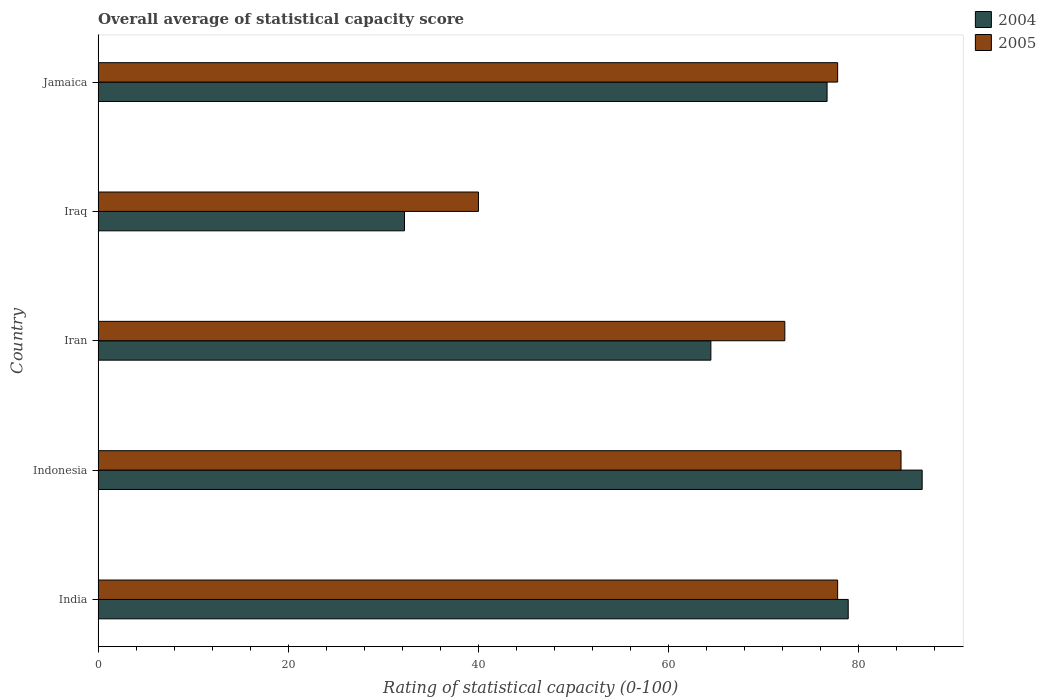How many groups of bars are there?
Give a very brief answer. 5. Are the number of bars per tick equal to the number of legend labels?
Provide a succinct answer. Yes. Are the number of bars on each tick of the Y-axis equal?
Provide a short and direct response. Yes. How many bars are there on the 2nd tick from the top?
Offer a terse response. 2. How many bars are there on the 5th tick from the bottom?
Your answer should be very brief. 2. What is the label of the 4th group of bars from the top?
Provide a succinct answer. Indonesia. In how many cases, is the number of bars for a given country not equal to the number of legend labels?
Offer a very short reply. 0. What is the rating of statistical capacity in 2004 in Iran?
Your answer should be very brief. 64.44. Across all countries, what is the maximum rating of statistical capacity in 2005?
Keep it short and to the point. 84.44. Across all countries, what is the minimum rating of statistical capacity in 2004?
Offer a terse response. 32.22. In which country was the rating of statistical capacity in 2004 maximum?
Provide a succinct answer. Indonesia. In which country was the rating of statistical capacity in 2005 minimum?
Make the answer very short. Iraq. What is the total rating of statistical capacity in 2004 in the graph?
Provide a succinct answer. 338.89. What is the difference between the rating of statistical capacity in 2004 in India and that in Indonesia?
Offer a very short reply. -7.78. What is the difference between the rating of statistical capacity in 2004 in Iran and the rating of statistical capacity in 2005 in Jamaica?
Offer a very short reply. -13.33. What is the average rating of statistical capacity in 2004 per country?
Ensure brevity in your answer.  67.78. What is the difference between the rating of statistical capacity in 2005 and rating of statistical capacity in 2004 in Indonesia?
Provide a succinct answer. -2.22. In how many countries, is the rating of statistical capacity in 2005 greater than 20 ?
Your answer should be very brief. 5. What is the ratio of the rating of statistical capacity in 2004 in Indonesia to that in Jamaica?
Offer a terse response. 1.13. What is the difference between the highest and the second highest rating of statistical capacity in 2004?
Provide a short and direct response. 7.78. What is the difference between the highest and the lowest rating of statistical capacity in 2005?
Make the answer very short. 44.44. In how many countries, is the rating of statistical capacity in 2005 greater than the average rating of statistical capacity in 2005 taken over all countries?
Your answer should be compact. 4. What does the 1st bar from the bottom in India represents?
Give a very brief answer. 2004. How many bars are there?
Your answer should be very brief. 10. What is the difference between two consecutive major ticks on the X-axis?
Give a very brief answer. 20. Are the values on the major ticks of X-axis written in scientific E-notation?
Keep it short and to the point. No. Where does the legend appear in the graph?
Offer a terse response. Top right. How are the legend labels stacked?
Make the answer very short. Vertical. What is the title of the graph?
Your answer should be very brief. Overall average of statistical capacity score. What is the label or title of the X-axis?
Provide a succinct answer. Rating of statistical capacity (0-100). What is the Rating of statistical capacity (0-100) of 2004 in India?
Offer a very short reply. 78.89. What is the Rating of statistical capacity (0-100) in 2005 in India?
Make the answer very short. 77.78. What is the Rating of statistical capacity (0-100) in 2004 in Indonesia?
Your answer should be very brief. 86.67. What is the Rating of statistical capacity (0-100) of 2005 in Indonesia?
Ensure brevity in your answer.  84.44. What is the Rating of statistical capacity (0-100) in 2004 in Iran?
Provide a short and direct response. 64.44. What is the Rating of statistical capacity (0-100) in 2005 in Iran?
Your answer should be compact. 72.22. What is the Rating of statistical capacity (0-100) of 2004 in Iraq?
Ensure brevity in your answer.  32.22. What is the Rating of statistical capacity (0-100) of 2004 in Jamaica?
Your answer should be very brief. 76.67. What is the Rating of statistical capacity (0-100) of 2005 in Jamaica?
Keep it short and to the point. 77.78. Across all countries, what is the maximum Rating of statistical capacity (0-100) in 2004?
Your answer should be very brief. 86.67. Across all countries, what is the maximum Rating of statistical capacity (0-100) in 2005?
Make the answer very short. 84.44. Across all countries, what is the minimum Rating of statistical capacity (0-100) in 2004?
Offer a terse response. 32.22. What is the total Rating of statistical capacity (0-100) of 2004 in the graph?
Your answer should be very brief. 338.89. What is the total Rating of statistical capacity (0-100) of 2005 in the graph?
Offer a terse response. 352.22. What is the difference between the Rating of statistical capacity (0-100) in 2004 in India and that in Indonesia?
Ensure brevity in your answer.  -7.78. What is the difference between the Rating of statistical capacity (0-100) in 2005 in India and that in Indonesia?
Make the answer very short. -6.67. What is the difference between the Rating of statistical capacity (0-100) in 2004 in India and that in Iran?
Provide a short and direct response. 14.44. What is the difference between the Rating of statistical capacity (0-100) of 2005 in India and that in Iran?
Provide a succinct answer. 5.56. What is the difference between the Rating of statistical capacity (0-100) in 2004 in India and that in Iraq?
Keep it short and to the point. 46.67. What is the difference between the Rating of statistical capacity (0-100) of 2005 in India and that in Iraq?
Your answer should be very brief. 37.78. What is the difference between the Rating of statistical capacity (0-100) in 2004 in India and that in Jamaica?
Provide a short and direct response. 2.22. What is the difference between the Rating of statistical capacity (0-100) of 2005 in India and that in Jamaica?
Provide a short and direct response. 0. What is the difference between the Rating of statistical capacity (0-100) in 2004 in Indonesia and that in Iran?
Ensure brevity in your answer.  22.22. What is the difference between the Rating of statistical capacity (0-100) in 2005 in Indonesia and that in Iran?
Your answer should be very brief. 12.22. What is the difference between the Rating of statistical capacity (0-100) of 2004 in Indonesia and that in Iraq?
Your answer should be compact. 54.44. What is the difference between the Rating of statistical capacity (0-100) in 2005 in Indonesia and that in Iraq?
Your response must be concise. 44.44. What is the difference between the Rating of statistical capacity (0-100) of 2004 in Indonesia and that in Jamaica?
Make the answer very short. 10. What is the difference between the Rating of statistical capacity (0-100) in 2004 in Iran and that in Iraq?
Offer a very short reply. 32.22. What is the difference between the Rating of statistical capacity (0-100) in 2005 in Iran and that in Iraq?
Ensure brevity in your answer.  32.22. What is the difference between the Rating of statistical capacity (0-100) of 2004 in Iran and that in Jamaica?
Give a very brief answer. -12.22. What is the difference between the Rating of statistical capacity (0-100) in 2005 in Iran and that in Jamaica?
Your response must be concise. -5.56. What is the difference between the Rating of statistical capacity (0-100) in 2004 in Iraq and that in Jamaica?
Make the answer very short. -44.44. What is the difference between the Rating of statistical capacity (0-100) of 2005 in Iraq and that in Jamaica?
Your response must be concise. -37.78. What is the difference between the Rating of statistical capacity (0-100) of 2004 in India and the Rating of statistical capacity (0-100) of 2005 in Indonesia?
Keep it short and to the point. -5.56. What is the difference between the Rating of statistical capacity (0-100) of 2004 in India and the Rating of statistical capacity (0-100) of 2005 in Iran?
Provide a succinct answer. 6.67. What is the difference between the Rating of statistical capacity (0-100) of 2004 in India and the Rating of statistical capacity (0-100) of 2005 in Iraq?
Your answer should be very brief. 38.89. What is the difference between the Rating of statistical capacity (0-100) in 2004 in India and the Rating of statistical capacity (0-100) in 2005 in Jamaica?
Provide a succinct answer. 1.11. What is the difference between the Rating of statistical capacity (0-100) in 2004 in Indonesia and the Rating of statistical capacity (0-100) in 2005 in Iran?
Provide a short and direct response. 14.44. What is the difference between the Rating of statistical capacity (0-100) of 2004 in Indonesia and the Rating of statistical capacity (0-100) of 2005 in Iraq?
Make the answer very short. 46.67. What is the difference between the Rating of statistical capacity (0-100) in 2004 in Indonesia and the Rating of statistical capacity (0-100) in 2005 in Jamaica?
Give a very brief answer. 8.89. What is the difference between the Rating of statistical capacity (0-100) in 2004 in Iran and the Rating of statistical capacity (0-100) in 2005 in Iraq?
Give a very brief answer. 24.44. What is the difference between the Rating of statistical capacity (0-100) of 2004 in Iran and the Rating of statistical capacity (0-100) of 2005 in Jamaica?
Keep it short and to the point. -13.33. What is the difference between the Rating of statistical capacity (0-100) in 2004 in Iraq and the Rating of statistical capacity (0-100) in 2005 in Jamaica?
Keep it short and to the point. -45.56. What is the average Rating of statistical capacity (0-100) in 2004 per country?
Keep it short and to the point. 67.78. What is the average Rating of statistical capacity (0-100) in 2005 per country?
Offer a terse response. 70.44. What is the difference between the Rating of statistical capacity (0-100) in 2004 and Rating of statistical capacity (0-100) in 2005 in Indonesia?
Your answer should be very brief. 2.22. What is the difference between the Rating of statistical capacity (0-100) in 2004 and Rating of statistical capacity (0-100) in 2005 in Iran?
Ensure brevity in your answer.  -7.78. What is the difference between the Rating of statistical capacity (0-100) in 2004 and Rating of statistical capacity (0-100) in 2005 in Iraq?
Offer a very short reply. -7.78. What is the difference between the Rating of statistical capacity (0-100) of 2004 and Rating of statistical capacity (0-100) of 2005 in Jamaica?
Make the answer very short. -1.11. What is the ratio of the Rating of statistical capacity (0-100) of 2004 in India to that in Indonesia?
Keep it short and to the point. 0.91. What is the ratio of the Rating of statistical capacity (0-100) in 2005 in India to that in Indonesia?
Make the answer very short. 0.92. What is the ratio of the Rating of statistical capacity (0-100) of 2004 in India to that in Iran?
Provide a short and direct response. 1.22. What is the ratio of the Rating of statistical capacity (0-100) in 2005 in India to that in Iran?
Keep it short and to the point. 1.08. What is the ratio of the Rating of statistical capacity (0-100) of 2004 in India to that in Iraq?
Your answer should be very brief. 2.45. What is the ratio of the Rating of statistical capacity (0-100) in 2005 in India to that in Iraq?
Ensure brevity in your answer.  1.94. What is the ratio of the Rating of statistical capacity (0-100) of 2004 in Indonesia to that in Iran?
Keep it short and to the point. 1.34. What is the ratio of the Rating of statistical capacity (0-100) of 2005 in Indonesia to that in Iran?
Keep it short and to the point. 1.17. What is the ratio of the Rating of statistical capacity (0-100) of 2004 in Indonesia to that in Iraq?
Provide a succinct answer. 2.69. What is the ratio of the Rating of statistical capacity (0-100) of 2005 in Indonesia to that in Iraq?
Your response must be concise. 2.11. What is the ratio of the Rating of statistical capacity (0-100) in 2004 in Indonesia to that in Jamaica?
Give a very brief answer. 1.13. What is the ratio of the Rating of statistical capacity (0-100) in 2005 in Indonesia to that in Jamaica?
Make the answer very short. 1.09. What is the ratio of the Rating of statistical capacity (0-100) of 2004 in Iran to that in Iraq?
Offer a very short reply. 2. What is the ratio of the Rating of statistical capacity (0-100) in 2005 in Iran to that in Iraq?
Provide a succinct answer. 1.81. What is the ratio of the Rating of statistical capacity (0-100) of 2004 in Iran to that in Jamaica?
Your answer should be compact. 0.84. What is the ratio of the Rating of statistical capacity (0-100) in 2005 in Iran to that in Jamaica?
Your answer should be compact. 0.93. What is the ratio of the Rating of statistical capacity (0-100) in 2004 in Iraq to that in Jamaica?
Make the answer very short. 0.42. What is the ratio of the Rating of statistical capacity (0-100) in 2005 in Iraq to that in Jamaica?
Your answer should be compact. 0.51. What is the difference between the highest and the second highest Rating of statistical capacity (0-100) of 2004?
Give a very brief answer. 7.78. What is the difference between the highest and the second highest Rating of statistical capacity (0-100) in 2005?
Your answer should be compact. 6.67. What is the difference between the highest and the lowest Rating of statistical capacity (0-100) in 2004?
Offer a terse response. 54.44. What is the difference between the highest and the lowest Rating of statistical capacity (0-100) of 2005?
Ensure brevity in your answer.  44.44. 